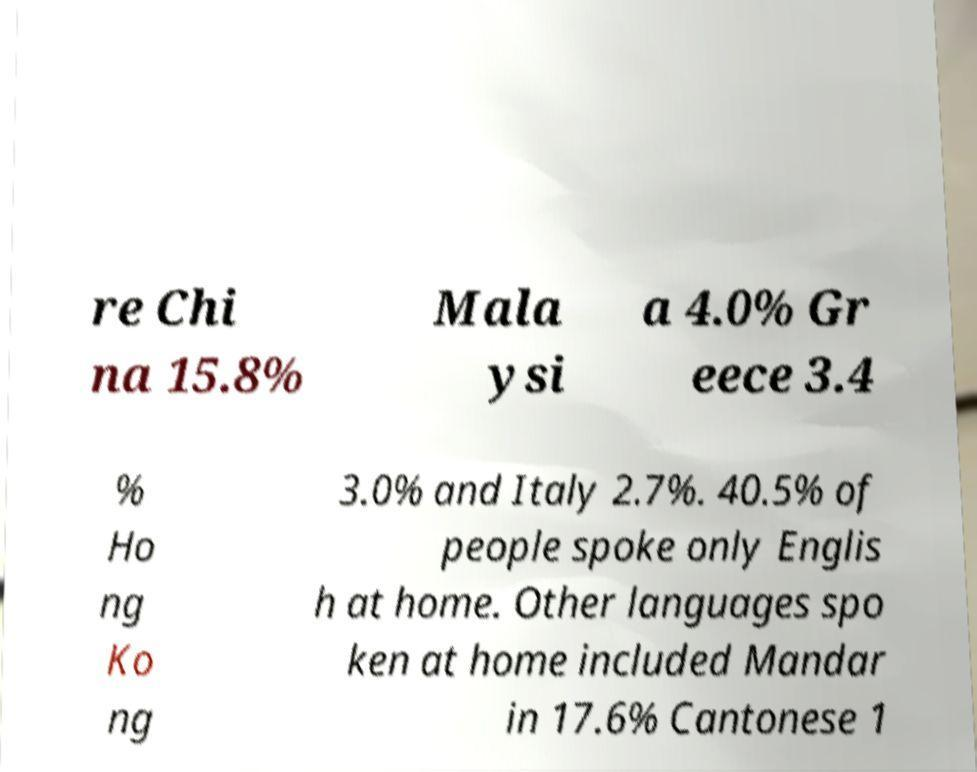There's text embedded in this image that I need extracted. Can you transcribe it verbatim? re Chi na 15.8% Mala ysi a 4.0% Gr eece 3.4 % Ho ng Ko ng 3.0% and Italy 2.7%. 40.5% of people spoke only Englis h at home. Other languages spo ken at home included Mandar in 17.6% Cantonese 1 